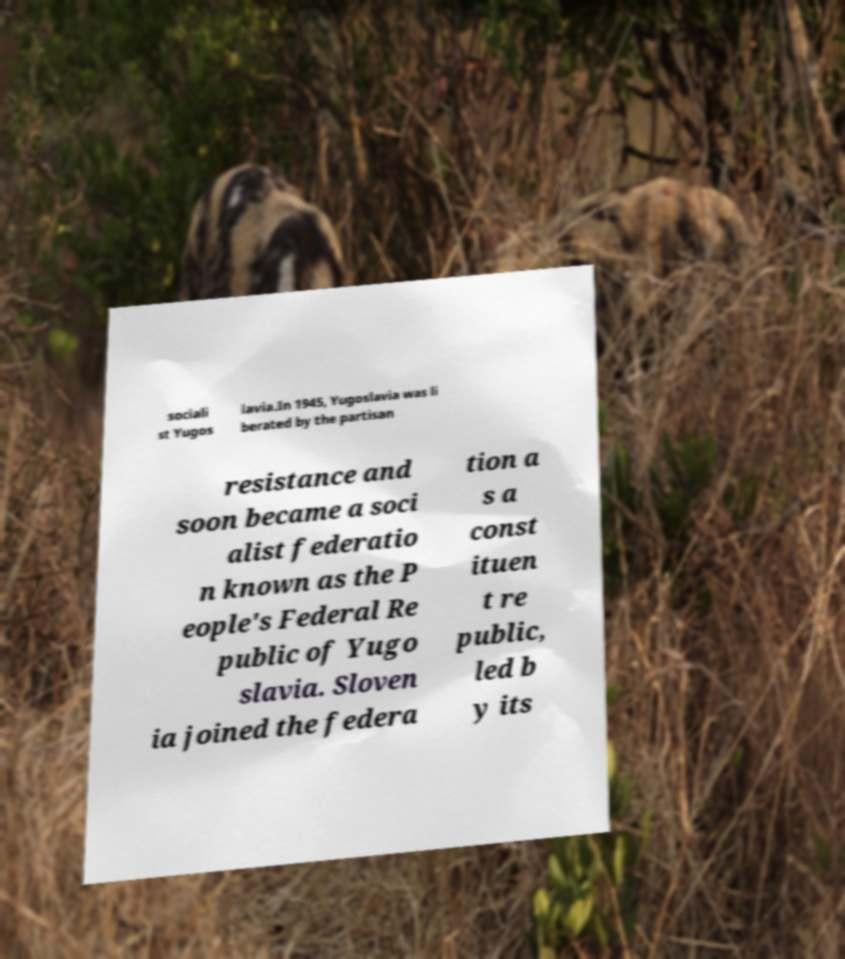What messages or text are displayed in this image? I need them in a readable, typed format. sociali st Yugos lavia.In 1945, Yugoslavia was li berated by the partisan resistance and soon became a soci alist federatio n known as the P eople's Federal Re public of Yugo slavia. Sloven ia joined the federa tion a s a const ituen t re public, led b y its 